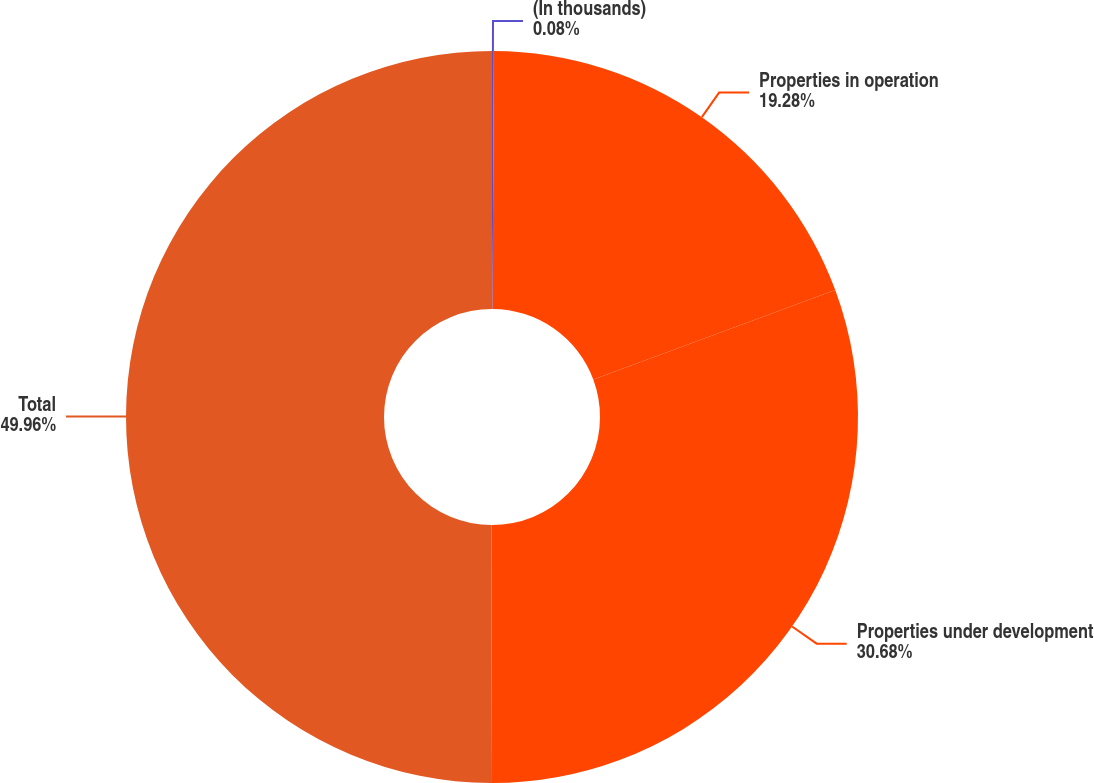<chart> <loc_0><loc_0><loc_500><loc_500><pie_chart><fcel>(In thousands)<fcel>Properties in operation<fcel>Properties under development<fcel>Total<nl><fcel>0.08%<fcel>19.28%<fcel>30.68%<fcel>49.96%<nl></chart> 